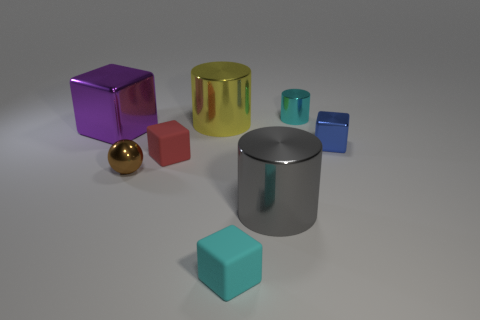There is a tiny matte thing that is the same color as the tiny cylinder; what shape is it?
Keep it short and to the point. Cube. How many other big purple blocks are the same material as the purple cube?
Keep it short and to the point. 0. What is the color of the large metal cube?
Provide a short and direct response. Purple. Do the cyan object behind the small cyan matte object and the big thing in front of the brown metal object have the same shape?
Ensure brevity in your answer.  Yes. What color is the large cylinder that is behind the big purple block?
Your answer should be very brief. Yellow. Are there fewer red rubber things that are in front of the metal ball than gray metallic cylinders behind the yellow thing?
Your answer should be very brief. No. How many other things are there of the same material as the small blue object?
Offer a terse response. 5. Are the brown object and the small cylinder made of the same material?
Give a very brief answer. Yes. What number of other objects are the same size as the brown shiny sphere?
Your answer should be compact. 4. There is a metallic thing on the right side of the cyan cylinder that is to the right of the tiny cyan matte block; what is its size?
Ensure brevity in your answer.  Small. 